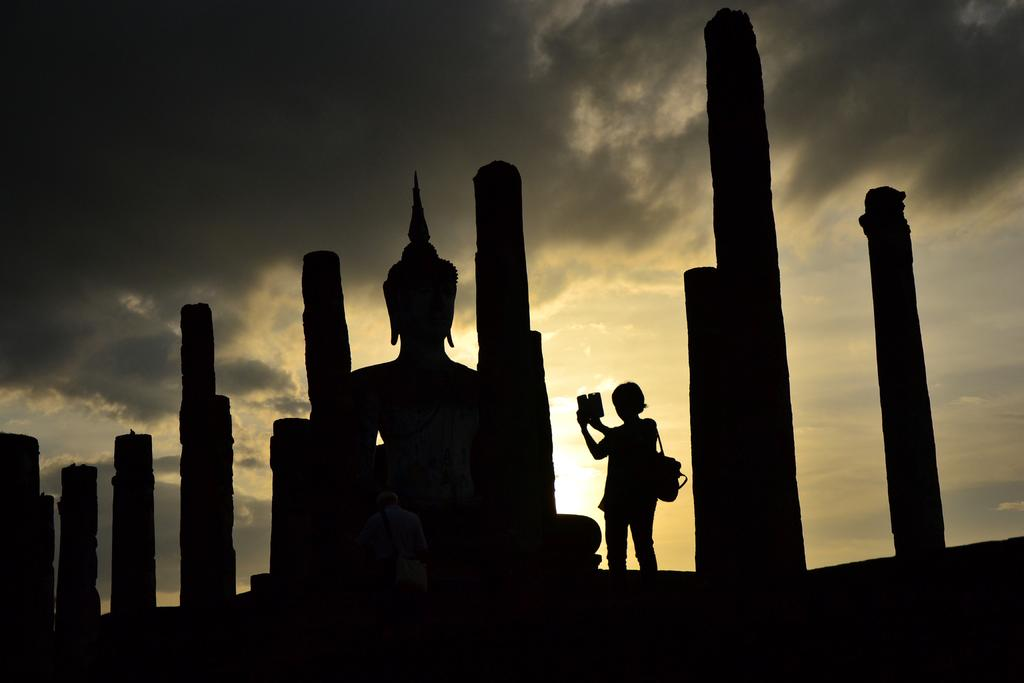What architectural features can be seen in the image? There are pillars in the image. What artistic element is present in the image? There is a sculpture in the image. What is the person in the image carrying on their back? The person is wearing a backpack in the image. What device is the person holding in the image? The person is holding a cell phone in the image. What celestial body is visible in the image? The sun is visible in the image. What atmospheric conditions can be observed in the image? There are clouds in the image. What part of the natural environment is visible in the image? The sky is visible in the image. Where is the comb located in the image? There is no comb present in the image. What type of desk can be seen in the image? There is no desk present in the image. 